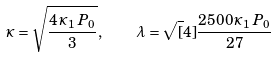Convert formula to latex. <formula><loc_0><loc_0><loc_500><loc_500>\varkappa = \sqrt { \frac { 4 \, \varkappa _ { 1 } \, P _ { 0 } } { 3 } } , \quad \lambda = \sqrt { [ } 4 ] { \frac { 2 5 0 0 \, \varkappa _ { 1 } \, P _ { 0 } } { 2 7 } }</formula> 